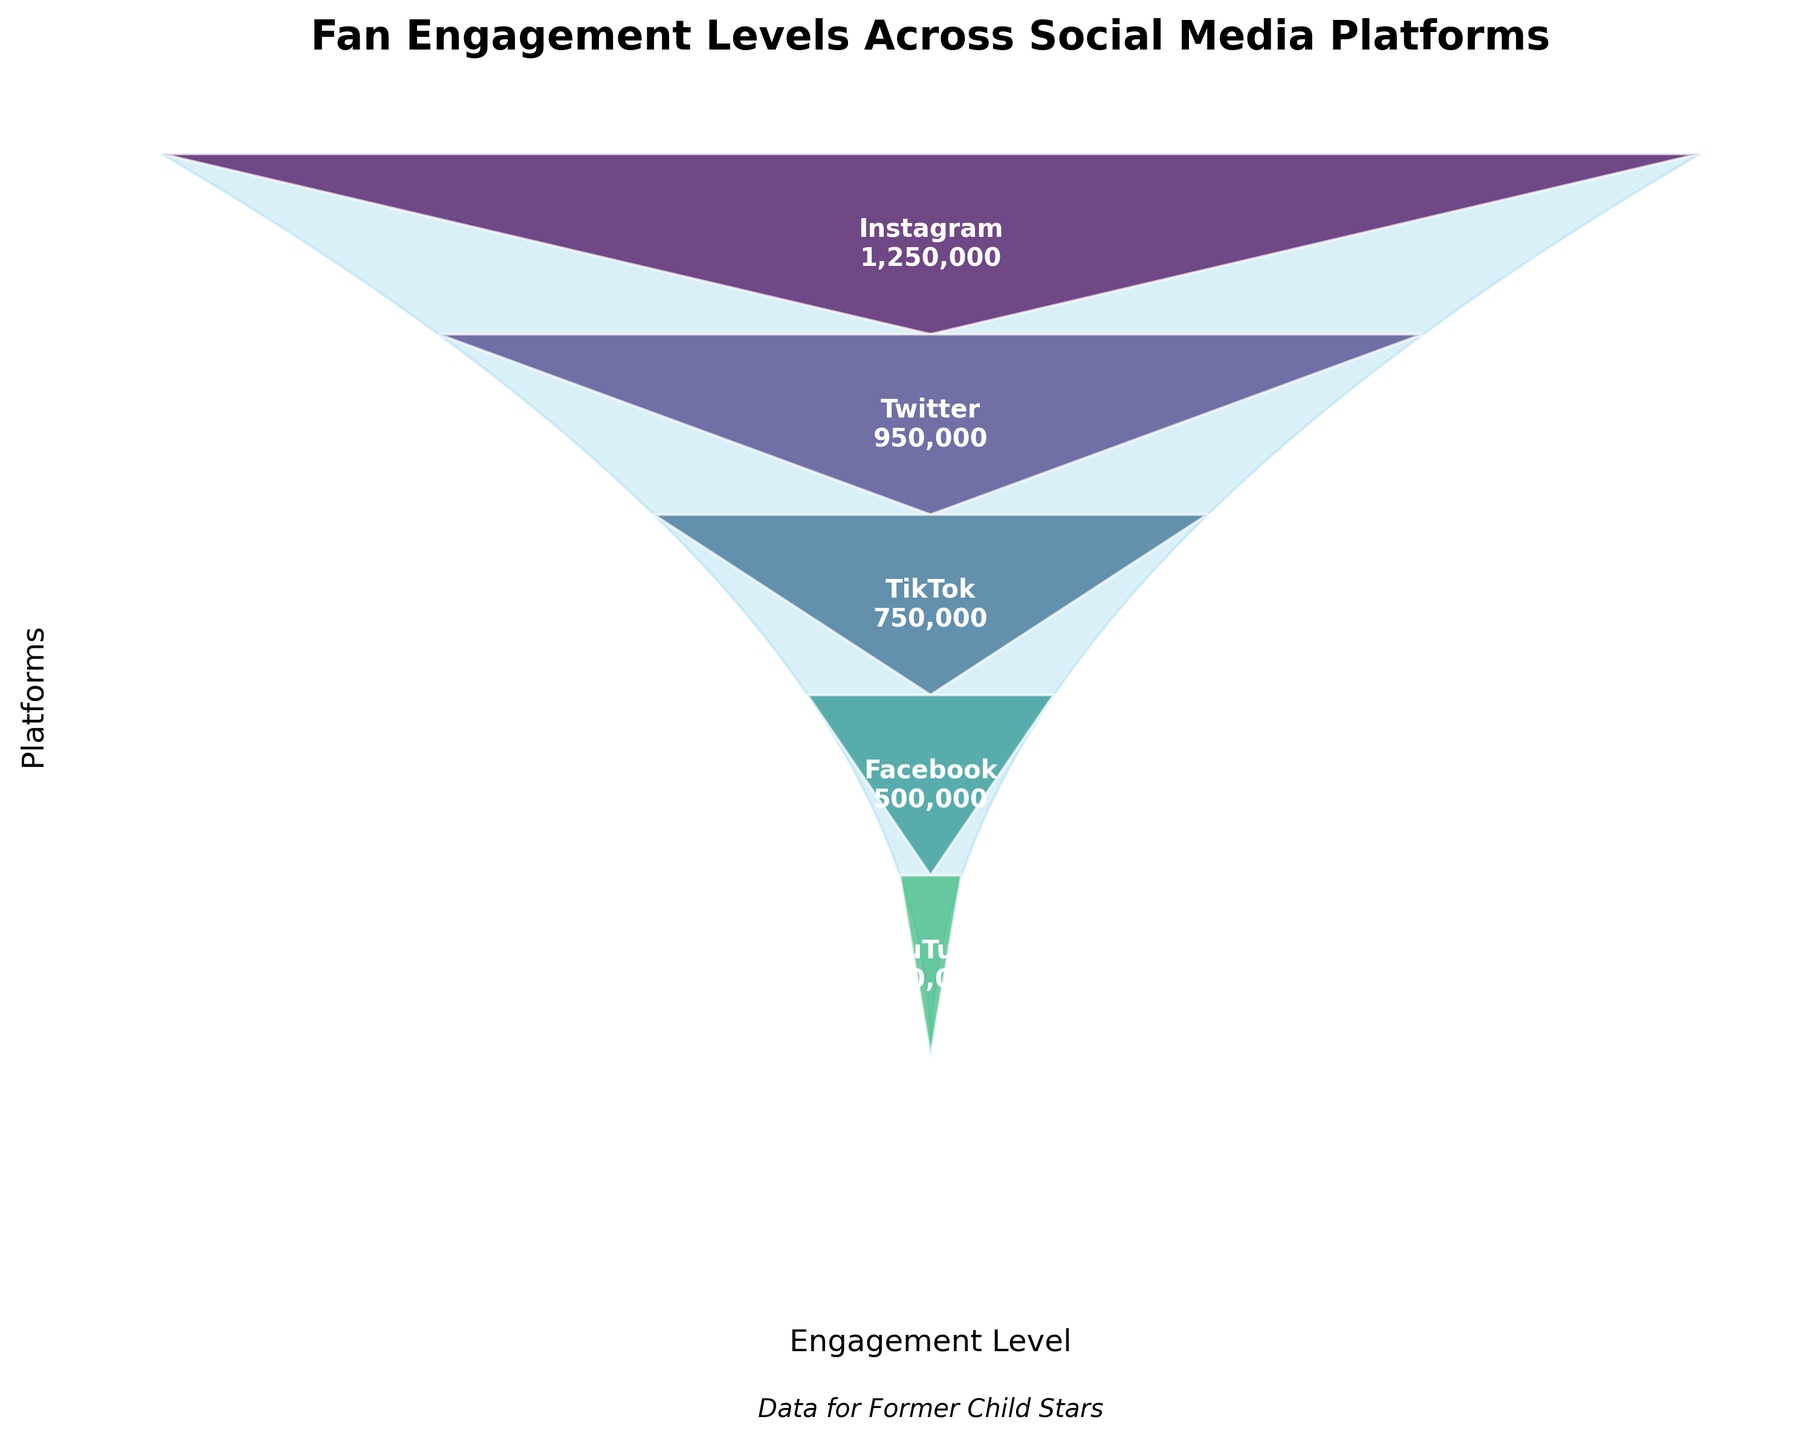What is the title of the chart? The title is located at the top of the chart and provides a summary of the visualized data.
Answer: Fan Engagement Levels Across Social Media Platforms Which platform has the highest engagement level? By looking at the top section of the funnel, the platform with the highest engagement level is shown.
Answer: Instagram How many platforms are displayed in the chart? By counting the distinct sections along the funnel, you can determine the number of platforms.
Answer: Six What are the engagement levels for TikTok and YouTube combined? Add the engagement levels of TikTok and YouTube from the labels. It's 750,000 (TikTok) + 350,000 (YouTube).
Answer: 1,100,000 Which platform has the lowest engagement level? By looking at the bottom section of the funnel, the platform with the lowest engagement level is shown.
Answer: LinkedIn How does Facebook's engagement level compare to LinkedIn's? Compare the values next to Facebook and LinkedIn. Identify the one with the higher number.
Answer: Facebook has a higher engagement level than LinkedIn What is the difference in engagement levels between Instagram and Facebook? Subtract Facebook's engagement level from Instagram's. It's 1,250,000 (Instagram) - 500,000 (Facebook).
Answer: 750,000 Which platform is ranked fourth in terms of engagement level? Identify the platform in the fourth section from the top.
Answer: Facebook What is the average engagement level across all platforms? Sum all the engagement levels and divide by the number of platforms. (1,250,000 + 950,000 + 750,000 + 500,000 + 350,000 + 150,000) / 6.
Answer: 658,333 Do most platforms fall above or below the median engagement level? Arrange the engagement levels in ascending order and find the middle value (median). Compare the count of platforms above and below this median. Median is between 500,000 and 750,000. Three platforms are above and three are below.
Answer: Equal 